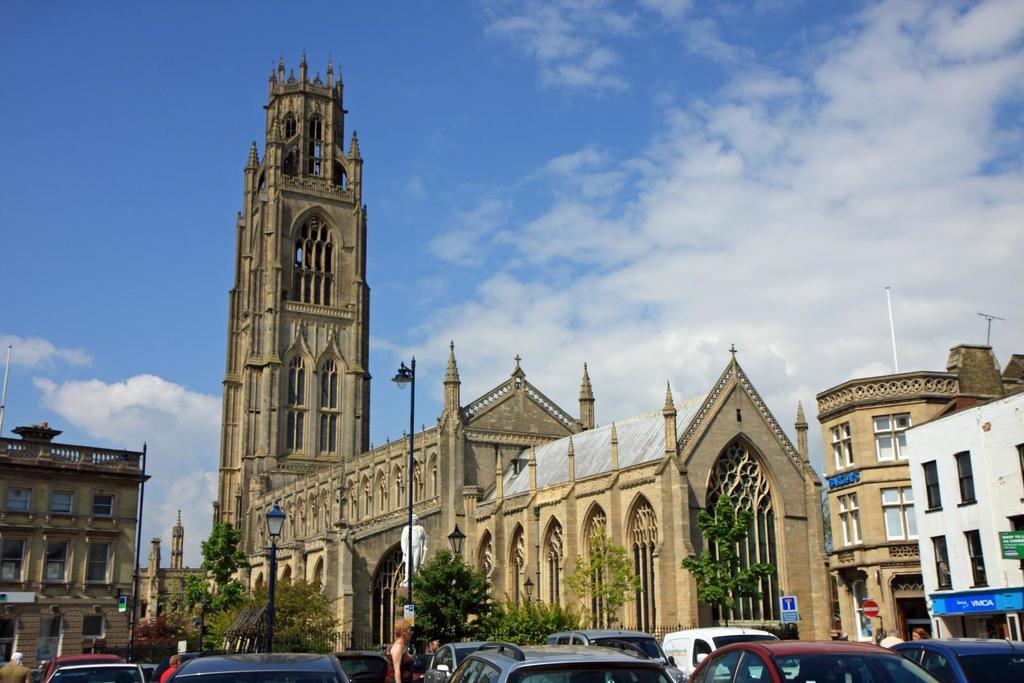What is the main subject of the image? There is a big brown color church in the center of the image. Can you describe the location of the church in the image? The church is in the center of the image. What else can be seen in the image besides the church? There are cars on the road in front of the church. What type of kite is flying over the church in the image? There is no kite present in the image; it only features a church and cars on the road. 